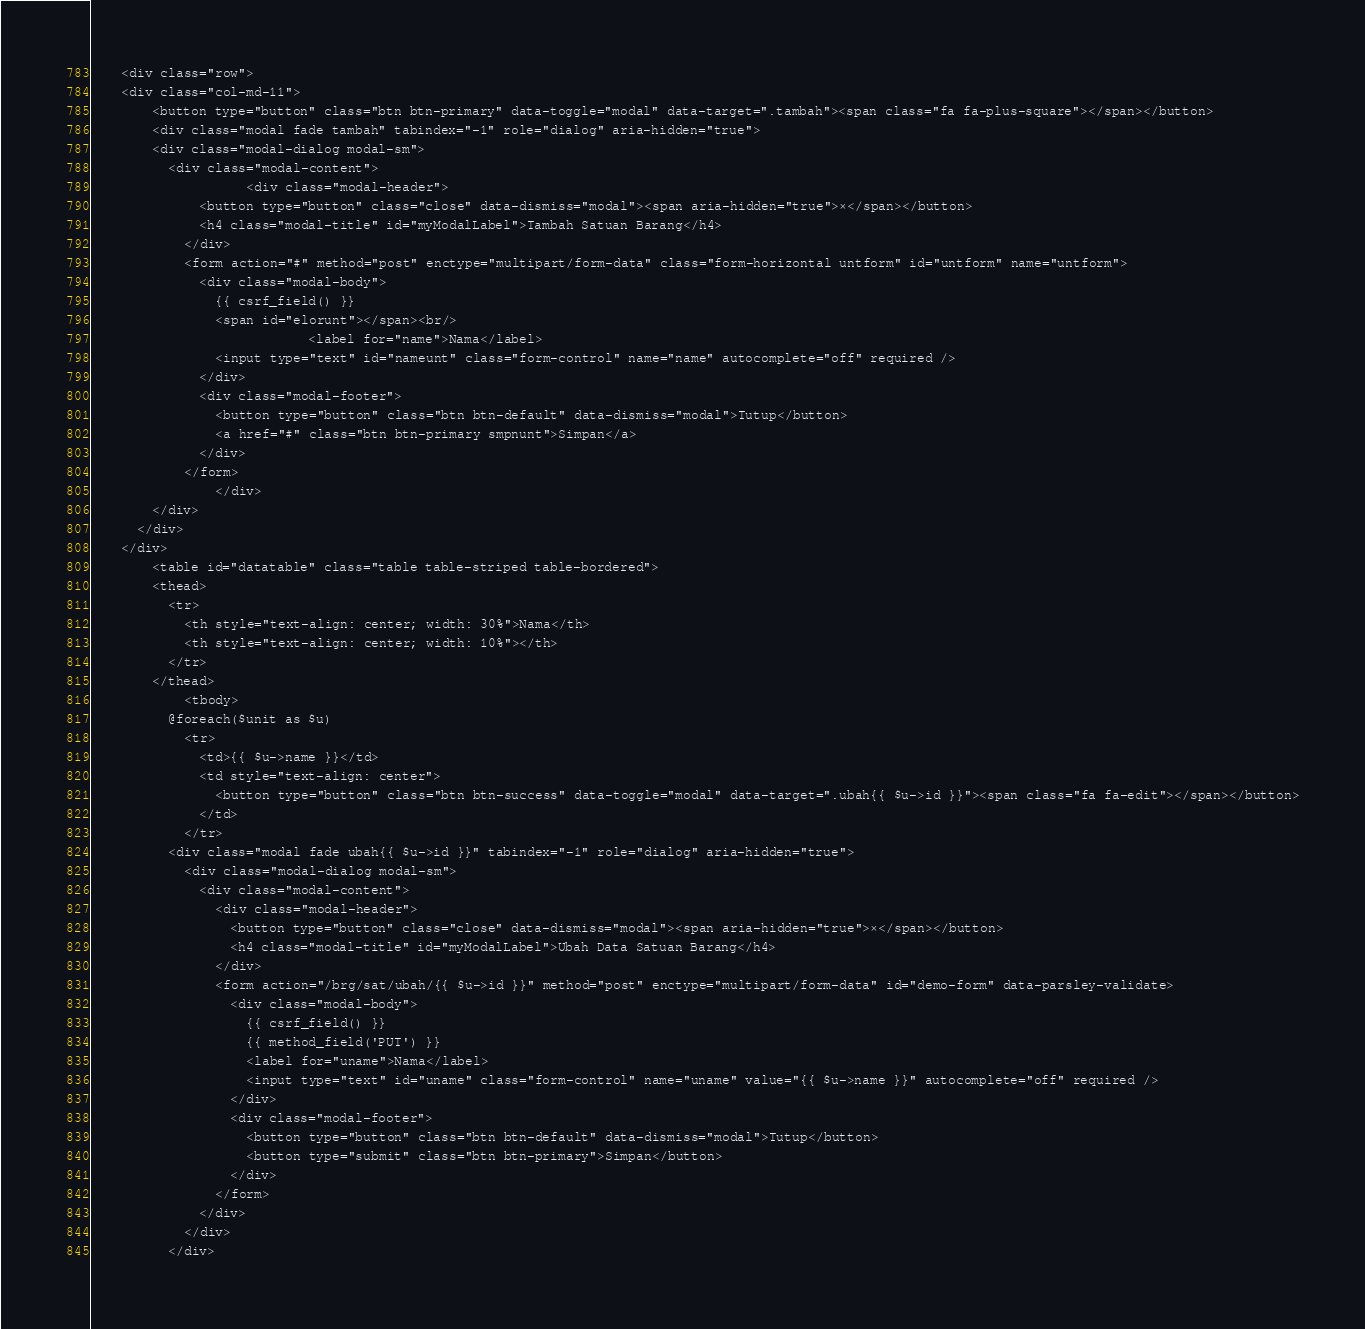<code> <loc_0><loc_0><loc_500><loc_500><_PHP_>	<div class="row">
    <div class="col-md-11">
  		<button type="button" class="btn btn-primary" data-toggle="modal" data-target=".tambah"><span class="fa fa-plus-square"></span></button>
  		<div class="modal fade tambah" tabindex="-1" role="dialog" aria-hidden="true">
        <div class="modal-dialog modal-sm">
          <div class="modal-content">
  					<div class="modal-header">
              <button type="button" class="close" data-dismiss="modal"><span aria-hidden="true">×</span></button>
              <h4 class="modal-title" id="myModalLabel">Tambah Satuan Barang</h4>
            </div>
            <form action="#" method="post" enctype="multipart/form-data" class="form-horizontal untform" id="untform" name="untform">
              <div class="modal-body">
                {{ csrf_field() }}
                <span id="elorunt"></span><br/>
  							<label for="name">Nama</label>
                <input type="text" id="nameunt" class="form-control" name="name" autocomplete="off" required />
              </div>
              <div class="modal-footer">
                <button type="button" class="btn btn-default" data-dismiss="modal">Tutup</button>
                <a href="#" class="btn btn-primary smpnunt">Simpan</a>
              </div>
            </form>
  				</div>
        </div>
      </div>
    </div>
  		<table id="datatable" class="table table-striped table-bordered">
        <thead>
          <tr>
            <th style="text-align: center; width: 30%">Nama</th>
            <th style="text-align: center; width: 10%"></th>
          </tr>
        </thead>
  			<tbody>
          @foreach($unit as $u)
            <tr>
              <td>{{ $u->name }}</td>
              <td style="text-align: center">
                <button type="button" class="btn btn-success" data-toggle="modal" data-target=".ubah{{ $u->id }}"><span class="fa fa-edit"></span></button>
              </td>
            </tr>
          <div class="modal fade ubah{{ $u->id }}" tabindex="-1" role="dialog" aria-hidden="true">
            <div class="modal-dialog modal-sm">
              <div class="modal-content">
                <div class="modal-header">
                  <button type="button" class="close" data-dismiss="modal"><span aria-hidden="true">×</span></button>
                  <h4 class="modal-title" id="myModalLabel">Ubah Data Satuan Barang</h4>
                </div>
                <form action="/brg/sat/ubah/{{ $u->id }}" method="post" enctype="multipart/form-data" id="demo-form" data-parsley-validate>
                  <div class="modal-body">
                    {{ csrf_field() }}
                    {{ method_field('PUT') }}
                    <label for="uname">Nama</label>
                    <input type="text" id="uname" class="form-control" name="uname" value="{{ $u->name }}" autocomplete="off" required />
                  </div>
                  <div class="modal-footer">
                    <button type="button" class="btn btn-default" data-dismiss="modal">Tutup</button>
                    <button type="submit" class="btn btn-primary">Simpan</button>
                  </div>
                </form>
              </div>
            </div>
          </div></code> 